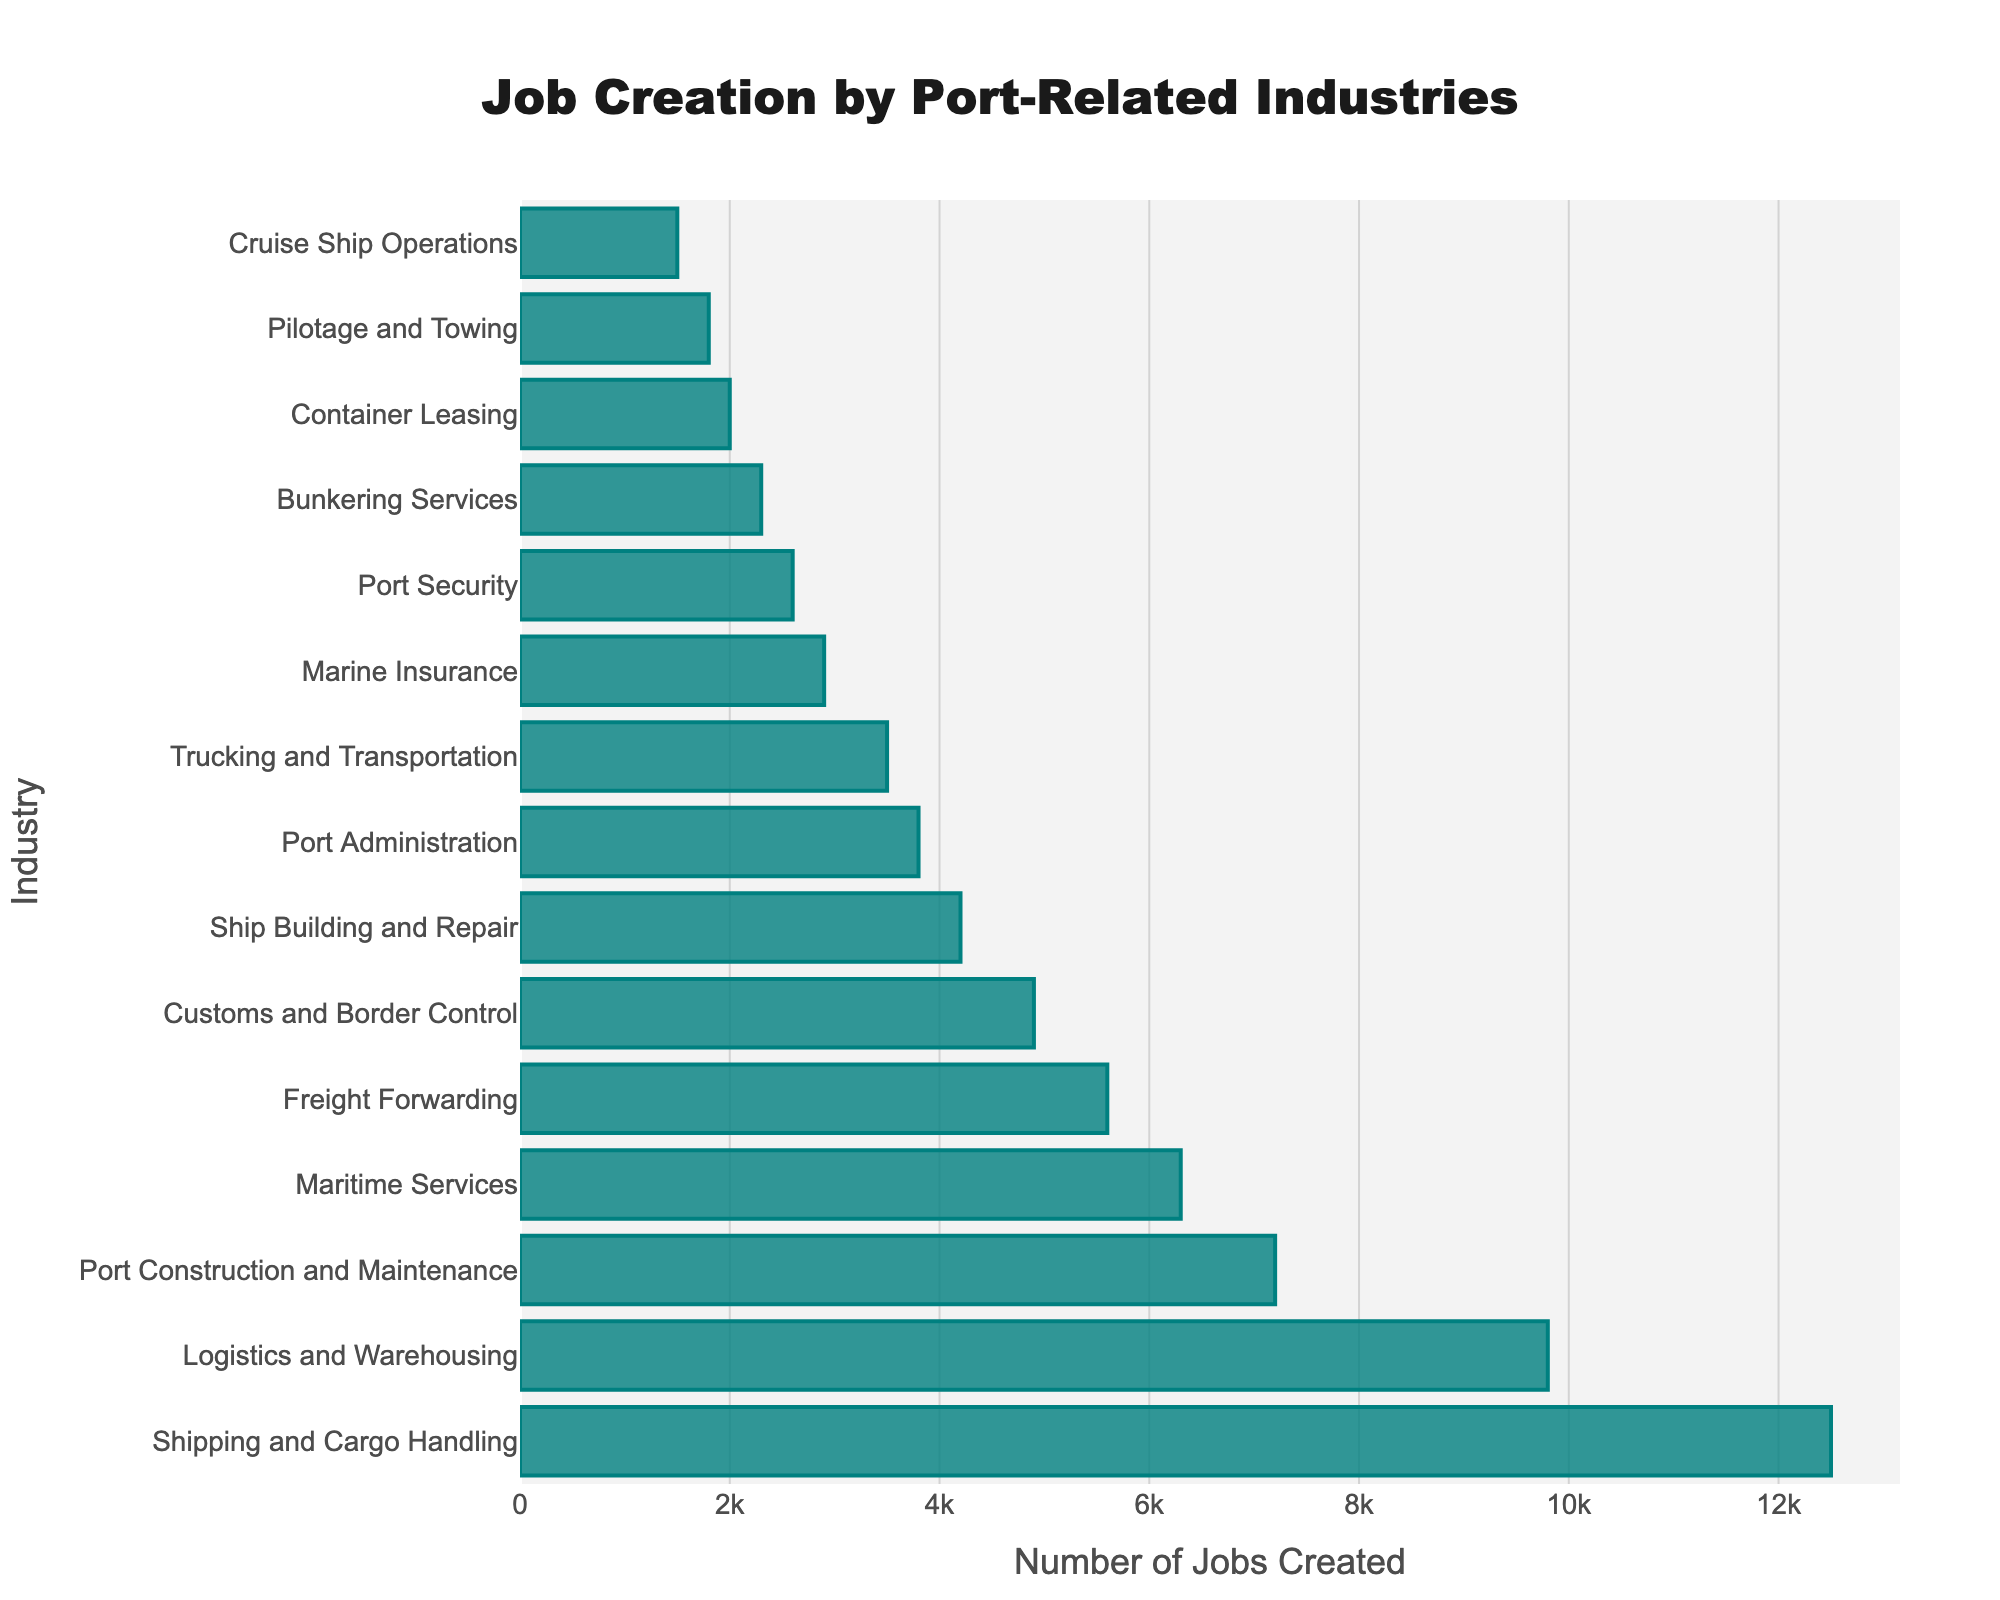Which industry creates the greatest number of jobs? The bar with the longest length represents the industry that creates the greatest number of jobs. In this case, it is Shipping and Cargo Handling.
Answer: Shipping and Cargo Handling Which industries create fewer than 3000 jobs? By observing any bars that do not extend past the 3000 mark on the x-axis, we can identify the industries: Marine Insurance, Port Security, Bunkering Services, Container Leasing, Pilotage and Towing, and Cruise Ship Operations.
Answer: Marine Insurance, Port Security, Bunkering Services, Container Leasing, Pilotage and Towing, Cruise Ship Operations What is the total number of jobs created by Freight Forwarding and Customs and Border Control combined? Adding the numbers from the respective bars: 5600 (Freight Forwarding) + 4900 (Customs and Border Control) = 10500.
Answer: 10500 What is the difference in job creation between Port Construction and Maintenance and Shipping and Cargo Handling? Subtract the number for Port Construction and Maintenance from Shipping and Cargo Handling: 12500 - 7200 = 5300.
Answer: 5300 Which industry creates more jobs, Port Administration or Trucking and Transportation? Compare the lengths of the bars; Trucking and Transportation (3500) is greater than Port Administration (3800).
Answer: Port Administration How many jobs are created on average by the industries listed? Calculate the mean by adding all the job creation figures and dividing by the number of industries (15): (12500 + 9800 + 7200 + 6300 + 5600 + 4900 + 4200 + 3800 + 3500 + 2900 + 2600 + 2300 + 2000 + 1800 + 1500) / 15 = 4706.67.
Answer: 4706.67 List the top three industries in terms of job creation. The longest three bars represent the industries creating the most jobs: Shipping and Cargo Handling, Logistics and Warehousing, and Port Construction and Maintenance.
Answer: Shipping and Cargo Handling, Logistics and Warehousing, Port Construction and Maintenance How many jobs are created by industries related to security (Port Security and Customs and Border Control combined)? Adding the numbers from the respective bars: 4900 (Customs and Border Control) + 2600 (Port Security) = 7500.
Answer: 7500 